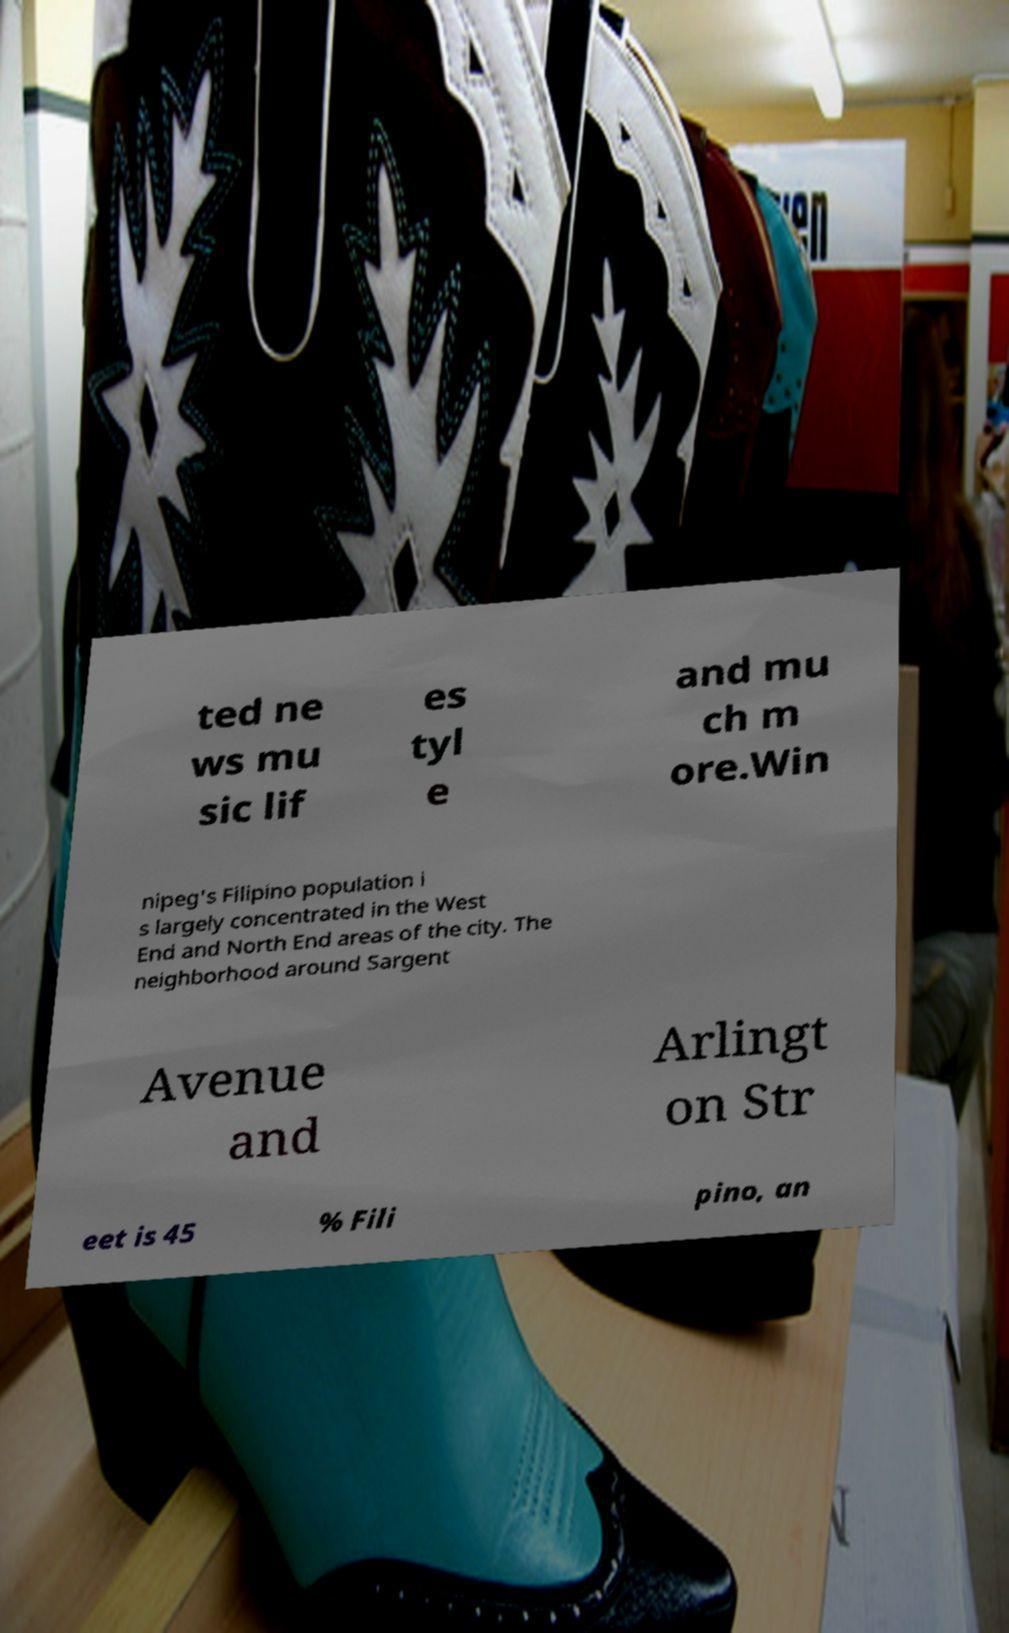I need the written content from this picture converted into text. Can you do that? ted ne ws mu sic lif es tyl e and mu ch m ore.Win nipeg's Filipino population i s largely concentrated in the West End and North End areas of the city. The neighborhood around Sargent Avenue and Arlingt on Str eet is 45 % Fili pino, an 